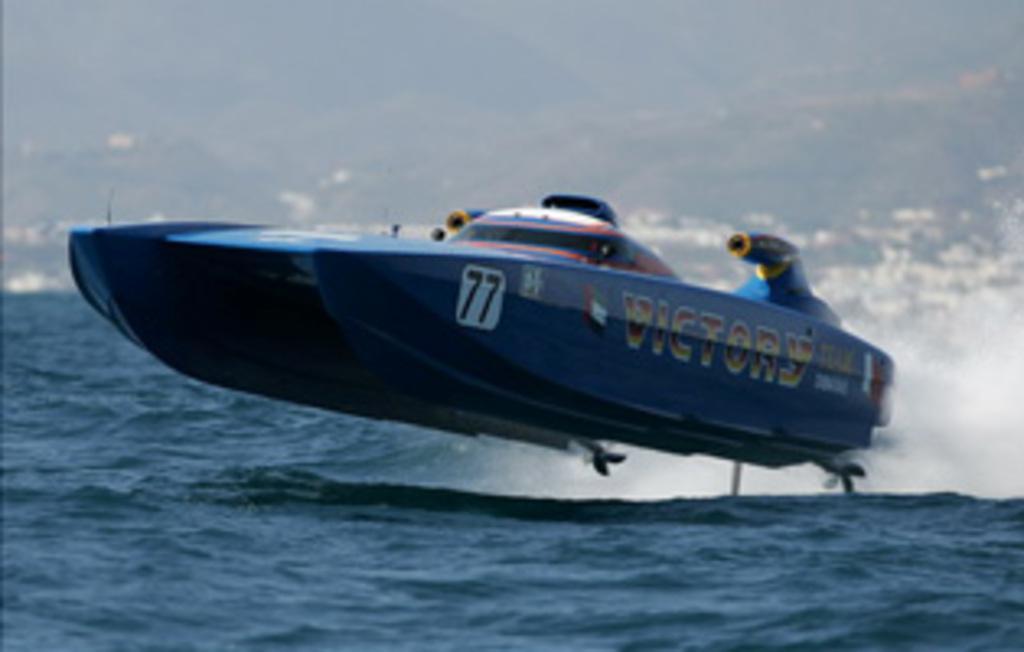Describe this image in one or two sentences. In this picture we can see boat above the water. In the background of the image it is blurry. 